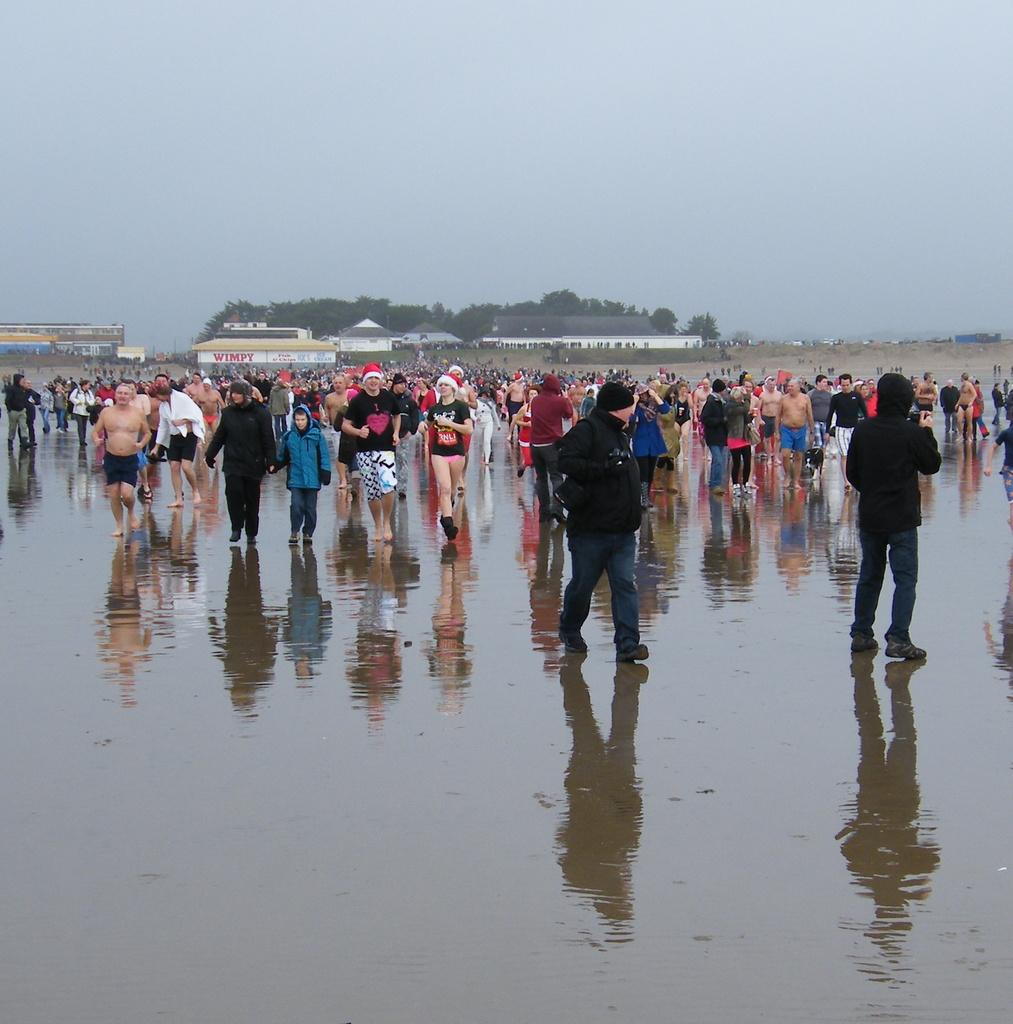What are the people in the image doing? There are people running and walking in the image. Where are the people located in the image? The people are on a path in the image. What can be seen in the background of the image? There are buildings, trees, and the sky visible in the background of the image. What type of hook is being used for teaching in the image? There is no hook or teaching activity present in the image. What kind of suit is the person wearing in the image? There are no people wearing suits in the image. 